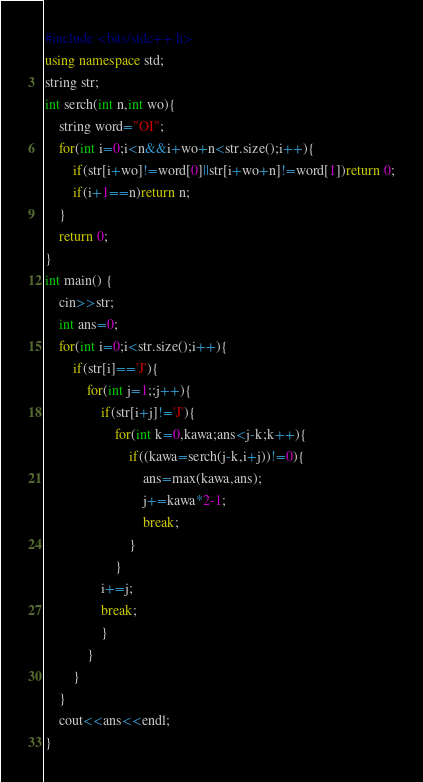<code> <loc_0><loc_0><loc_500><loc_500><_C++_>#include <bits/stdc++.h>
using namespace std;
string str;
int serch(int n,int wo){
    string word="OI";
    for(int i=0;i<n&&i+wo+n<str.size();i++){
        if(str[i+wo]!=word[0]||str[i+wo+n]!=word[1])return 0;
        if(i+1==n)return n;
    }
    return 0;
}
int main() {
    cin>>str;
    int ans=0;
    for(int i=0;i<str.size();i++){
        if(str[i]=='J'){
            for(int j=1;;j++){
                if(str[i+j]!='J'){
                    for(int k=0,kawa;ans<j-k;k++){
                        if((kawa=serch(j-k,i+j))!=0){
                        	ans=max(kawa,ans);
                        	j+=kawa*2-1;
                        	break;
                        }
                    }
                i+=j;
                break;
                }
            }
        }
    }
    cout<<ans<<endl;
}</code> 